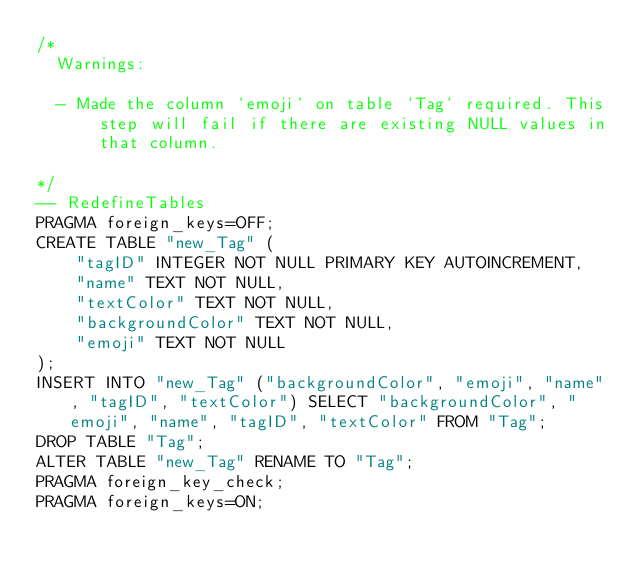<code> <loc_0><loc_0><loc_500><loc_500><_SQL_>/*
  Warnings:

  - Made the column `emoji` on table `Tag` required. This step will fail if there are existing NULL values in that column.

*/
-- RedefineTables
PRAGMA foreign_keys=OFF;
CREATE TABLE "new_Tag" (
    "tagID" INTEGER NOT NULL PRIMARY KEY AUTOINCREMENT,
    "name" TEXT NOT NULL,
    "textColor" TEXT NOT NULL,
    "backgroundColor" TEXT NOT NULL,
    "emoji" TEXT NOT NULL
);
INSERT INTO "new_Tag" ("backgroundColor", "emoji", "name", "tagID", "textColor") SELECT "backgroundColor", "emoji", "name", "tagID", "textColor" FROM "Tag";
DROP TABLE "Tag";
ALTER TABLE "new_Tag" RENAME TO "Tag";
PRAGMA foreign_key_check;
PRAGMA foreign_keys=ON;
</code> 